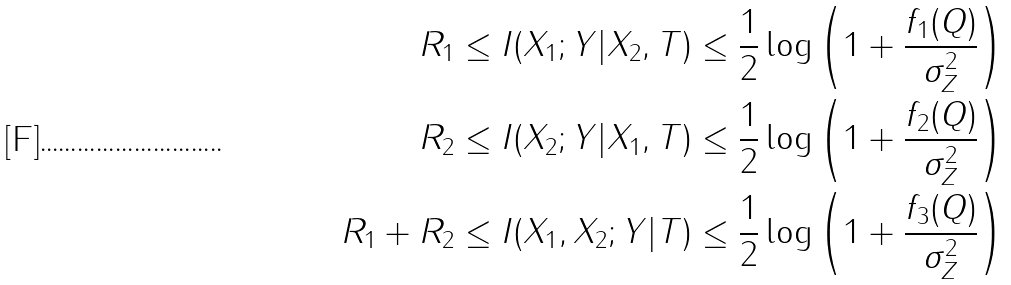Convert formula to latex. <formula><loc_0><loc_0><loc_500><loc_500>R _ { 1 } & \leq I ( X _ { 1 } ; Y | X _ { 2 } , T ) \leq \frac { 1 } { 2 } \log \left ( 1 + \frac { f _ { 1 } ( Q ) } { \sigma _ { Z } ^ { 2 } } \right ) \\ R _ { 2 } & \leq I ( X _ { 2 } ; Y | X _ { 1 } , T ) \leq \frac { 1 } { 2 } \log \left ( 1 + \frac { f _ { 2 } ( Q ) } { \sigma _ { Z } ^ { 2 } } \right ) \\ R _ { 1 } + R _ { 2 } & \leq I ( X _ { 1 } , X _ { 2 } ; Y | T ) \leq \frac { 1 } { 2 } \log \left ( 1 + \frac { f _ { 3 } ( Q ) } { \sigma _ { Z } ^ { 2 } } \right )</formula> 